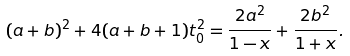Convert formula to latex. <formula><loc_0><loc_0><loc_500><loc_500>( a + b ) ^ { 2 } + 4 ( a + b + 1 ) t _ { 0 } ^ { 2 } = \frac { 2 a ^ { 2 } } { 1 - x } + \frac { 2 b ^ { 2 } } { 1 + x } .</formula> 